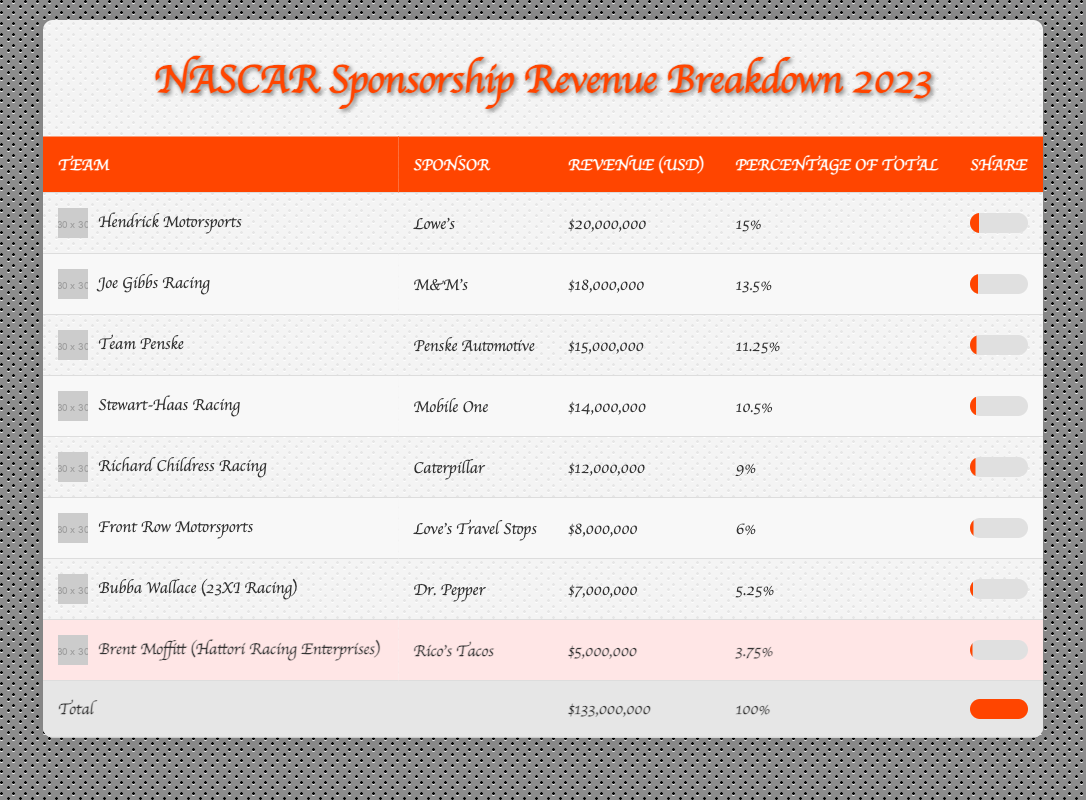What is the total sponsorship revenue for NASCAR teams in 2023? The table lists a total revenue of $133,000,000 in the last row designated as "Total."
Answer: 133,000,000 Which team has the largest sponsorship revenue and what is the amount? The team with the largest sponsorship revenue is Hendrick Motorsports, which generated $20,000,000 as listed in the first row.
Answer: 20,000,000 How much revenue does Brent Moffitt's team generate compared to the total revenue? Brent Moffitt's team generated $5,000,000, and to find the percentage of total revenue, we use the formula (5,000,000 / 133,000,000) * 100 which equals approximately 3.75%. This matches the percentage listed in the table for his team.
Answer: 3.75% Are there any teams that generated more than $15,000,000 in revenue? By examining the revenue column, teams like Hendrick Motorsports ($20,000,000), Joe Gibbs Racing ($18,000,000), and Team Penske ($15,000,000) generated more than $15,000,000. Therefore, the answer is yes.
Answer: Yes What is the average sponsorship revenue of the top three teams? The revenue for the top three teams is $20,000,000 (Hendrick Motorsports) + $18,000,000 (Joe Gibbs Racing) + $15,000,000 (Team Penske), which adds up to $53,000,000. We then divide by 3 (the number of teams) to find the average, resulting in $53,000,000 / 3 = $17,666,667.
Answer: 17,666,667 How much revenue does the team with the least sponsorship revenue generate? The last row of the table shows that Brent Moffitt's team generates the least revenue of $5,000,000.
Answer: 5,000,000 Which sponsor is associated with Richard Childress Racing, and how much revenue do they provide? The table shows that the sponsor for Richard Childress Racing is Caterpillar, which provides $12,000,000 in revenue as listed in the fifth row.
Answer: Caterpillar, 12,000,000 Is the revenue of Front Row Motorsports more or less than the average revenue of all teams? The average revenue is calculated from the total revenue of $133,000,000 divided by the number of teams, which is 8, giving an average of $16,625,000. Front Row Motorsports generated $8,000,000, which is less than the average.
Answer: Less How much revenue is generated by the three teams with the highest sponsorship revenue? Adding the revenues of Hendrick Motorsports ($20,000,000), Joe Gibbs Racing ($18,000,000), and Team Penske ($15,000,000) gives a total of $53,000,000 generated by the top three teams.
Answer: 53,000,000 